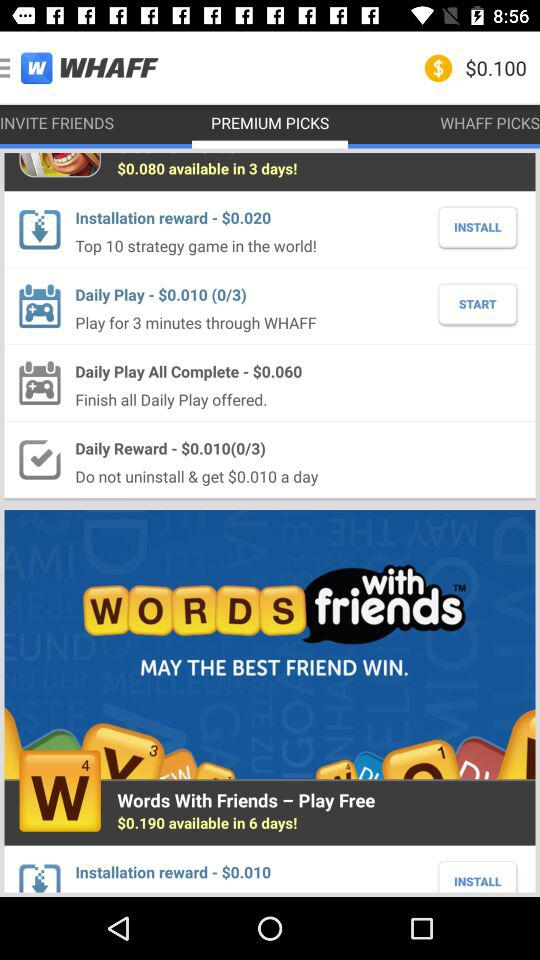What is the amount of daily play? The amount of daily play is $0.010. 